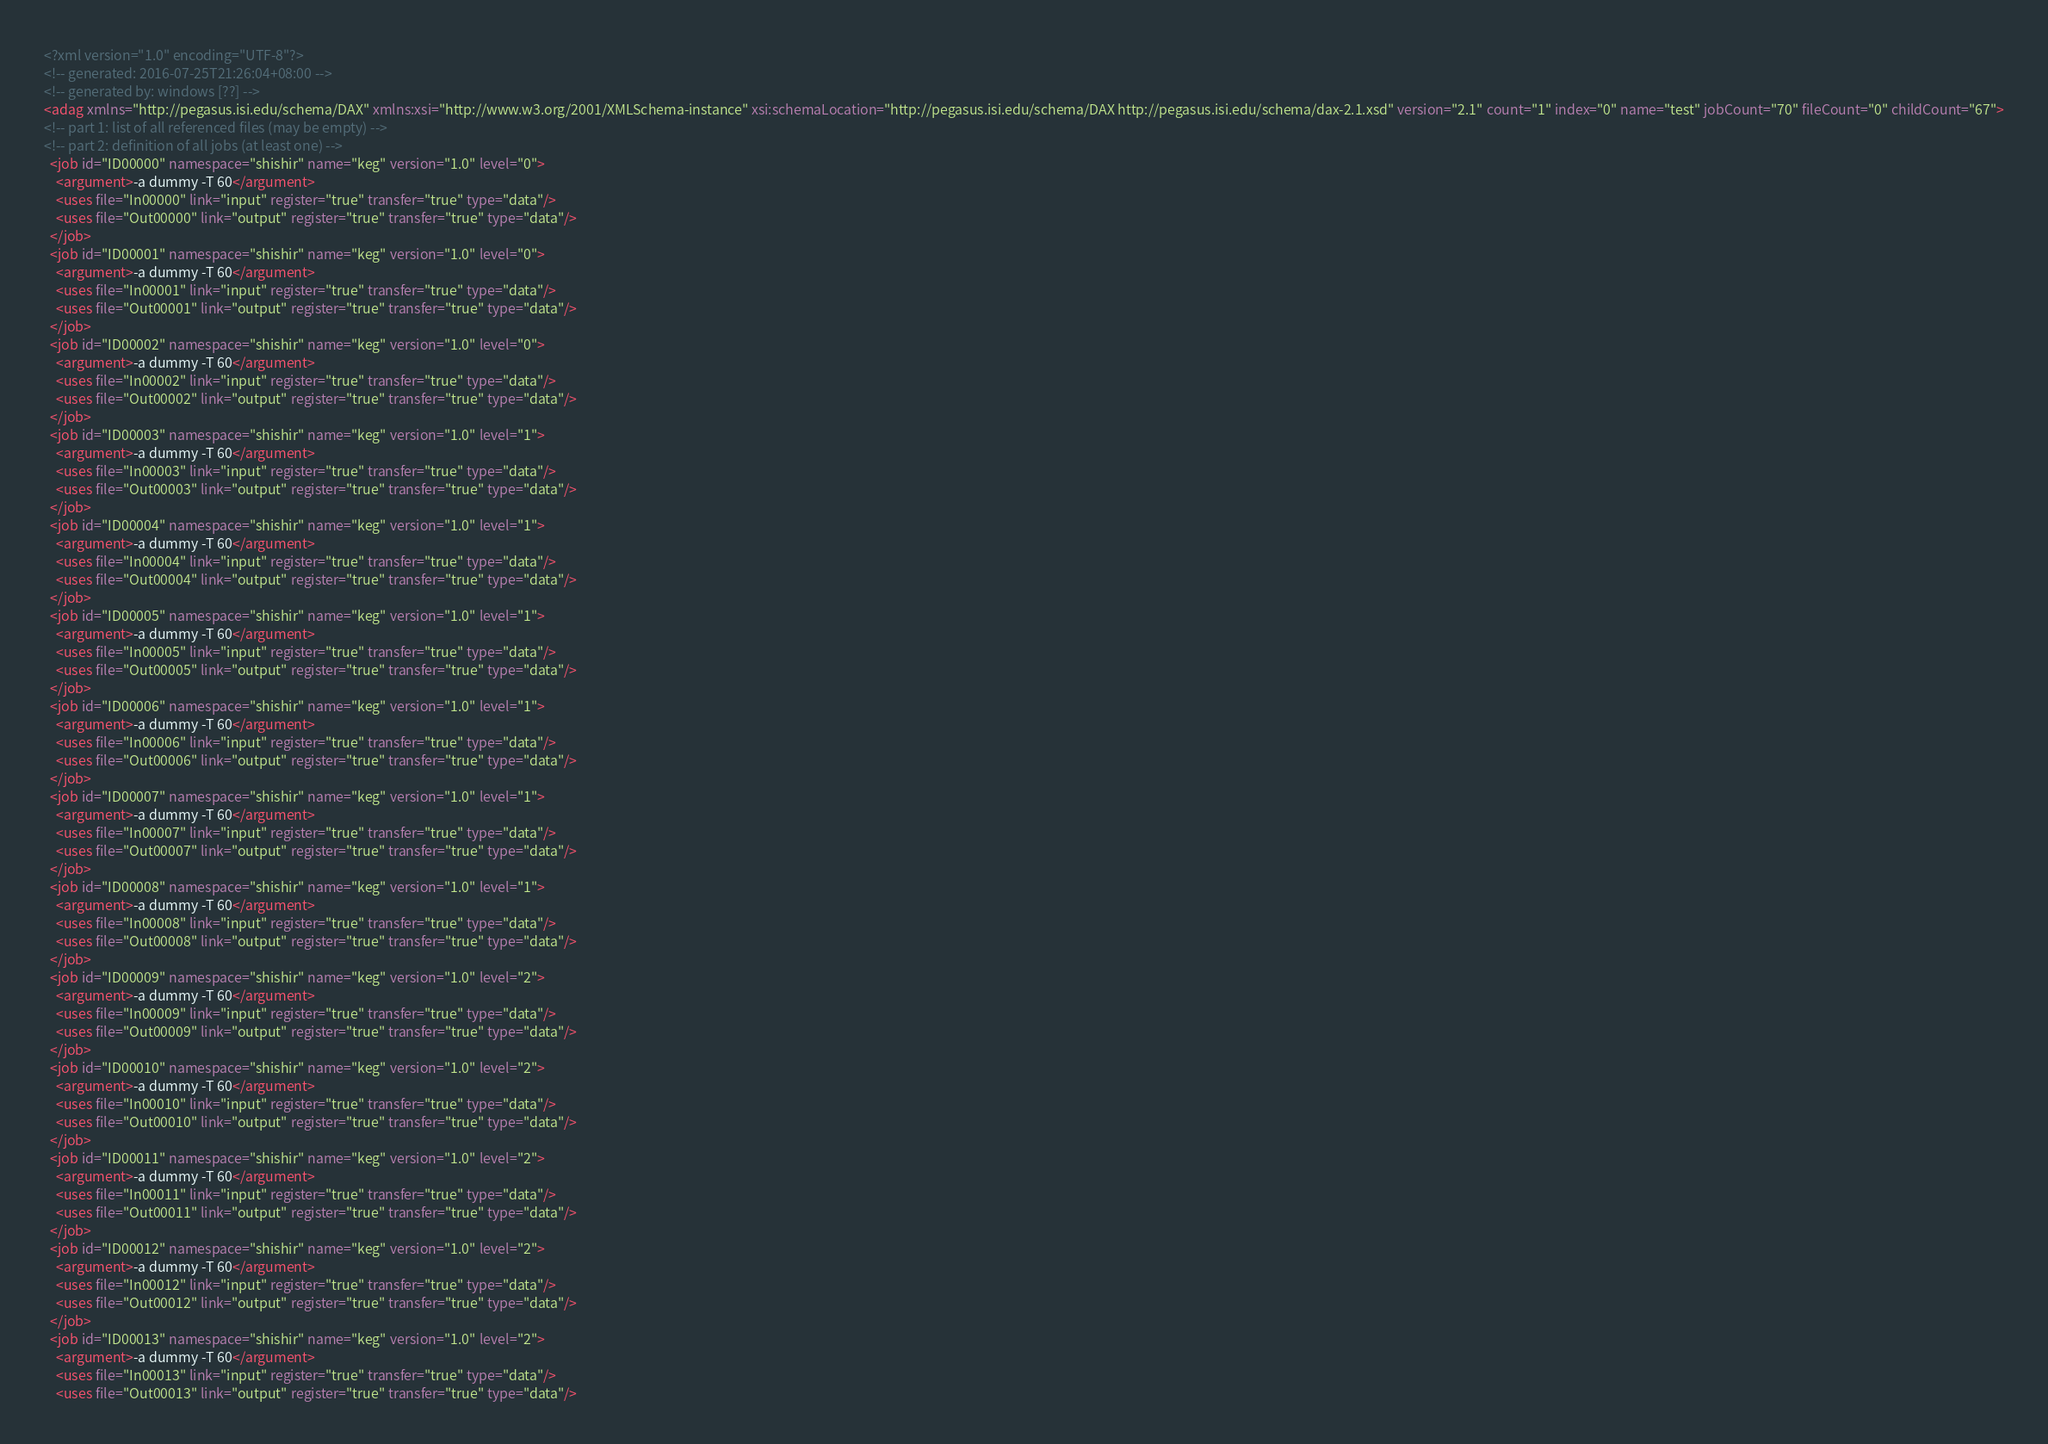Convert code to text. <code><loc_0><loc_0><loc_500><loc_500><_XML_><?xml version="1.0" encoding="UTF-8"?>
<!-- generated: 2016-07-25T21:26:04+08:00 -->
<!-- generated by: windows [??] -->
<adag xmlns="http://pegasus.isi.edu/schema/DAX" xmlns:xsi="http://www.w3.org/2001/XMLSchema-instance" xsi:schemaLocation="http://pegasus.isi.edu/schema/DAX http://pegasus.isi.edu/schema/dax-2.1.xsd" version="2.1" count="1" index="0" name="test" jobCount="70" fileCount="0" childCount="67">
<!-- part 1: list of all referenced files (may be empty) -->
<!-- part 2: definition of all jobs (at least one) -->
  <job id="ID00000" namespace="shishir" name="keg" version="1.0" level="0">
    <argument>-a dummy -T 60</argument>
    <uses file="In00000" link="input" register="true" transfer="true" type="data"/>
    <uses file="Out00000" link="output" register="true" transfer="true" type="data"/>
  </job>
  <job id="ID00001" namespace="shishir" name="keg" version="1.0" level="0">
    <argument>-a dummy -T 60</argument>
    <uses file="In00001" link="input" register="true" transfer="true" type="data"/>
    <uses file="Out00001" link="output" register="true" transfer="true" type="data"/>
  </job>
  <job id="ID00002" namespace="shishir" name="keg" version="1.0" level="0">
    <argument>-a dummy -T 60</argument>
    <uses file="In00002" link="input" register="true" transfer="true" type="data"/>
    <uses file="Out00002" link="output" register="true" transfer="true" type="data"/>
  </job>
  <job id="ID00003" namespace="shishir" name="keg" version="1.0" level="1">
    <argument>-a dummy -T 60</argument>
    <uses file="In00003" link="input" register="true" transfer="true" type="data"/>
    <uses file="Out00003" link="output" register="true" transfer="true" type="data"/>
  </job>
  <job id="ID00004" namespace="shishir" name="keg" version="1.0" level="1">
    <argument>-a dummy -T 60</argument>
    <uses file="In00004" link="input" register="true" transfer="true" type="data"/>
    <uses file="Out00004" link="output" register="true" transfer="true" type="data"/>
  </job>
  <job id="ID00005" namespace="shishir" name="keg" version="1.0" level="1">
    <argument>-a dummy -T 60</argument>
    <uses file="In00005" link="input" register="true" transfer="true" type="data"/>
    <uses file="Out00005" link="output" register="true" transfer="true" type="data"/>
  </job>
  <job id="ID00006" namespace="shishir" name="keg" version="1.0" level="1">
    <argument>-a dummy -T 60</argument>
    <uses file="In00006" link="input" register="true" transfer="true" type="data"/>
    <uses file="Out00006" link="output" register="true" transfer="true" type="data"/>
  </job>
  <job id="ID00007" namespace="shishir" name="keg" version="1.0" level="1">
    <argument>-a dummy -T 60</argument>
    <uses file="In00007" link="input" register="true" transfer="true" type="data"/>
    <uses file="Out00007" link="output" register="true" transfer="true" type="data"/>
  </job>
  <job id="ID00008" namespace="shishir" name="keg" version="1.0" level="1">
    <argument>-a dummy -T 60</argument>
    <uses file="In00008" link="input" register="true" transfer="true" type="data"/>
    <uses file="Out00008" link="output" register="true" transfer="true" type="data"/>
  </job>
  <job id="ID00009" namespace="shishir" name="keg" version="1.0" level="2">
    <argument>-a dummy -T 60</argument>
    <uses file="In00009" link="input" register="true" transfer="true" type="data"/>
    <uses file="Out00009" link="output" register="true" transfer="true" type="data"/>
  </job>
  <job id="ID00010" namespace="shishir" name="keg" version="1.0" level="2">
    <argument>-a dummy -T 60</argument>
    <uses file="In00010" link="input" register="true" transfer="true" type="data"/>
    <uses file="Out00010" link="output" register="true" transfer="true" type="data"/>
  </job>
  <job id="ID00011" namespace="shishir" name="keg" version="1.0" level="2">
    <argument>-a dummy -T 60</argument>
    <uses file="In00011" link="input" register="true" transfer="true" type="data"/>
    <uses file="Out00011" link="output" register="true" transfer="true" type="data"/>
  </job>
  <job id="ID00012" namespace="shishir" name="keg" version="1.0" level="2">
    <argument>-a dummy -T 60</argument>
    <uses file="In00012" link="input" register="true" transfer="true" type="data"/>
    <uses file="Out00012" link="output" register="true" transfer="true" type="data"/>
  </job>
  <job id="ID00013" namespace="shishir" name="keg" version="1.0" level="2">
    <argument>-a dummy -T 60</argument>
    <uses file="In00013" link="input" register="true" transfer="true" type="data"/>
    <uses file="Out00013" link="output" register="true" transfer="true" type="data"/></code> 